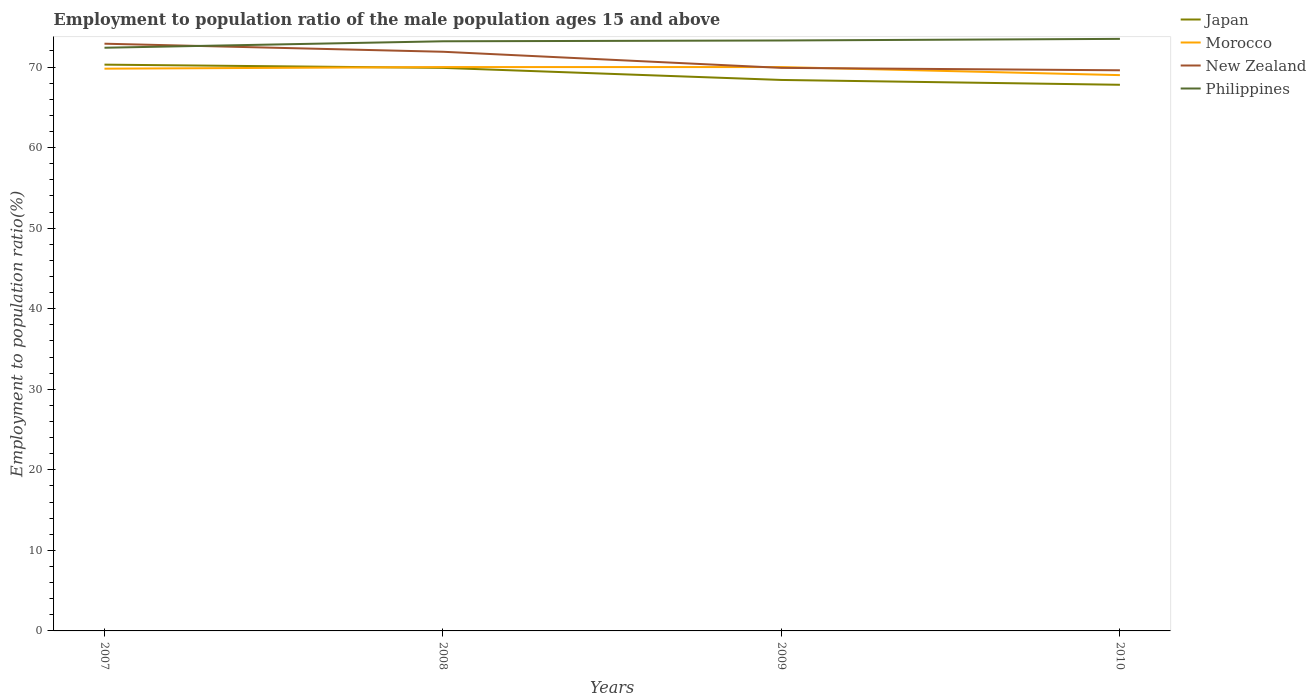How many different coloured lines are there?
Provide a succinct answer. 4. Does the line corresponding to Philippines intersect with the line corresponding to New Zealand?
Your answer should be compact. Yes. Across all years, what is the maximum employment to population ratio in New Zealand?
Give a very brief answer. 69.6. In which year was the employment to population ratio in Japan maximum?
Offer a very short reply. 2010. What is the total employment to population ratio in New Zealand in the graph?
Offer a very short reply. 2.3. How many years are there in the graph?
Ensure brevity in your answer.  4. Does the graph contain any zero values?
Your response must be concise. No. Where does the legend appear in the graph?
Provide a succinct answer. Top right. How are the legend labels stacked?
Give a very brief answer. Vertical. What is the title of the graph?
Make the answer very short. Employment to population ratio of the male population ages 15 and above. Does "Dominica" appear as one of the legend labels in the graph?
Your answer should be very brief. No. What is the Employment to population ratio(%) in Japan in 2007?
Make the answer very short. 70.3. What is the Employment to population ratio(%) in Morocco in 2007?
Give a very brief answer. 69.8. What is the Employment to population ratio(%) of New Zealand in 2007?
Your answer should be very brief. 72.9. What is the Employment to population ratio(%) of Philippines in 2007?
Keep it short and to the point. 72.4. What is the Employment to population ratio(%) in Japan in 2008?
Offer a very short reply. 69.9. What is the Employment to population ratio(%) in Morocco in 2008?
Provide a succinct answer. 70. What is the Employment to population ratio(%) of New Zealand in 2008?
Offer a very short reply. 71.9. What is the Employment to population ratio(%) of Philippines in 2008?
Provide a short and direct response. 73.2. What is the Employment to population ratio(%) in Japan in 2009?
Ensure brevity in your answer.  68.4. What is the Employment to population ratio(%) of New Zealand in 2009?
Keep it short and to the point. 69.9. What is the Employment to population ratio(%) in Philippines in 2009?
Give a very brief answer. 73.3. What is the Employment to population ratio(%) of Japan in 2010?
Provide a short and direct response. 67.8. What is the Employment to population ratio(%) in New Zealand in 2010?
Provide a succinct answer. 69.6. What is the Employment to population ratio(%) of Philippines in 2010?
Provide a succinct answer. 73.5. Across all years, what is the maximum Employment to population ratio(%) in Japan?
Provide a succinct answer. 70.3. Across all years, what is the maximum Employment to population ratio(%) of Morocco?
Your response must be concise. 70. Across all years, what is the maximum Employment to population ratio(%) of New Zealand?
Your answer should be very brief. 72.9. Across all years, what is the maximum Employment to population ratio(%) of Philippines?
Give a very brief answer. 73.5. Across all years, what is the minimum Employment to population ratio(%) of Japan?
Make the answer very short. 67.8. Across all years, what is the minimum Employment to population ratio(%) of New Zealand?
Offer a terse response. 69.6. Across all years, what is the minimum Employment to population ratio(%) of Philippines?
Your answer should be compact. 72.4. What is the total Employment to population ratio(%) in Japan in the graph?
Ensure brevity in your answer.  276.4. What is the total Employment to population ratio(%) of Morocco in the graph?
Ensure brevity in your answer.  278.8. What is the total Employment to population ratio(%) of New Zealand in the graph?
Keep it short and to the point. 284.3. What is the total Employment to population ratio(%) in Philippines in the graph?
Your answer should be very brief. 292.4. What is the difference between the Employment to population ratio(%) in Japan in 2007 and that in 2008?
Provide a short and direct response. 0.4. What is the difference between the Employment to population ratio(%) of Morocco in 2007 and that in 2008?
Provide a succinct answer. -0.2. What is the difference between the Employment to population ratio(%) of Philippines in 2007 and that in 2008?
Offer a terse response. -0.8. What is the difference between the Employment to population ratio(%) of Morocco in 2007 and that in 2009?
Make the answer very short. -0.2. What is the difference between the Employment to population ratio(%) of Japan in 2007 and that in 2010?
Provide a short and direct response. 2.5. What is the difference between the Employment to population ratio(%) of Japan in 2008 and that in 2009?
Your answer should be compact. 1.5. What is the difference between the Employment to population ratio(%) in Morocco in 2008 and that in 2009?
Your response must be concise. 0. What is the difference between the Employment to population ratio(%) of New Zealand in 2008 and that in 2009?
Ensure brevity in your answer.  2. What is the difference between the Employment to population ratio(%) in Philippines in 2008 and that in 2009?
Ensure brevity in your answer.  -0.1. What is the difference between the Employment to population ratio(%) of New Zealand in 2008 and that in 2010?
Provide a short and direct response. 2.3. What is the difference between the Employment to population ratio(%) of Japan in 2009 and that in 2010?
Your answer should be very brief. 0.6. What is the difference between the Employment to population ratio(%) of Philippines in 2009 and that in 2010?
Provide a succinct answer. -0.2. What is the difference between the Employment to population ratio(%) in Japan in 2007 and the Employment to population ratio(%) in New Zealand in 2008?
Offer a terse response. -1.6. What is the difference between the Employment to population ratio(%) of Japan in 2007 and the Employment to population ratio(%) of Philippines in 2008?
Provide a succinct answer. -2.9. What is the difference between the Employment to population ratio(%) of Morocco in 2007 and the Employment to population ratio(%) of New Zealand in 2008?
Offer a very short reply. -2.1. What is the difference between the Employment to population ratio(%) of New Zealand in 2007 and the Employment to population ratio(%) of Philippines in 2008?
Your answer should be very brief. -0.3. What is the difference between the Employment to population ratio(%) of Japan in 2007 and the Employment to population ratio(%) of Philippines in 2009?
Give a very brief answer. -3. What is the difference between the Employment to population ratio(%) of Morocco in 2007 and the Employment to population ratio(%) of Philippines in 2009?
Your answer should be compact. -3.5. What is the difference between the Employment to population ratio(%) in New Zealand in 2007 and the Employment to population ratio(%) in Philippines in 2010?
Provide a short and direct response. -0.6. What is the difference between the Employment to population ratio(%) of Japan in 2008 and the Employment to population ratio(%) of Morocco in 2009?
Ensure brevity in your answer.  -0.1. What is the difference between the Employment to population ratio(%) of Japan in 2008 and the Employment to population ratio(%) of Philippines in 2009?
Give a very brief answer. -3.4. What is the difference between the Employment to population ratio(%) of Morocco in 2008 and the Employment to population ratio(%) of New Zealand in 2009?
Offer a terse response. 0.1. What is the difference between the Employment to population ratio(%) in Morocco in 2008 and the Employment to population ratio(%) in Philippines in 2009?
Your response must be concise. -3.3. What is the difference between the Employment to population ratio(%) in New Zealand in 2008 and the Employment to population ratio(%) in Philippines in 2009?
Provide a succinct answer. -1.4. What is the difference between the Employment to population ratio(%) of Japan in 2008 and the Employment to population ratio(%) of Morocco in 2010?
Provide a succinct answer. 0.9. What is the difference between the Employment to population ratio(%) in Morocco in 2008 and the Employment to population ratio(%) in New Zealand in 2010?
Ensure brevity in your answer.  0.4. What is the difference between the Employment to population ratio(%) in Morocco in 2008 and the Employment to population ratio(%) in Philippines in 2010?
Ensure brevity in your answer.  -3.5. What is the difference between the Employment to population ratio(%) of New Zealand in 2008 and the Employment to population ratio(%) of Philippines in 2010?
Make the answer very short. -1.6. What is the difference between the Employment to population ratio(%) of Japan in 2009 and the Employment to population ratio(%) of Morocco in 2010?
Give a very brief answer. -0.6. What is the difference between the Employment to population ratio(%) in Japan in 2009 and the Employment to population ratio(%) in Philippines in 2010?
Your answer should be very brief. -5.1. What is the difference between the Employment to population ratio(%) of Morocco in 2009 and the Employment to population ratio(%) of New Zealand in 2010?
Make the answer very short. 0.4. What is the difference between the Employment to population ratio(%) in New Zealand in 2009 and the Employment to population ratio(%) in Philippines in 2010?
Offer a terse response. -3.6. What is the average Employment to population ratio(%) in Japan per year?
Your response must be concise. 69.1. What is the average Employment to population ratio(%) in Morocco per year?
Provide a short and direct response. 69.7. What is the average Employment to population ratio(%) in New Zealand per year?
Your answer should be very brief. 71.08. What is the average Employment to population ratio(%) in Philippines per year?
Offer a terse response. 73.1. In the year 2007, what is the difference between the Employment to population ratio(%) of Japan and Employment to population ratio(%) of New Zealand?
Provide a short and direct response. -2.6. In the year 2007, what is the difference between the Employment to population ratio(%) in Japan and Employment to population ratio(%) in Philippines?
Ensure brevity in your answer.  -2.1. In the year 2007, what is the difference between the Employment to population ratio(%) of Morocco and Employment to population ratio(%) of Philippines?
Provide a short and direct response. -2.6. In the year 2008, what is the difference between the Employment to population ratio(%) in Japan and Employment to population ratio(%) in Philippines?
Your response must be concise. -3.3. In the year 2009, what is the difference between the Employment to population ratio(%) in Japan and Employment to population ratio(%) in Morocco?
Provide a short and direct response. -1.6. In the year 2010, what is the difference between the Employment to population ratio(%) of Japan and Employment to population ratio(%) of Morocco?
Offer a very short reply. -1.2. In the year 2010, what is the difference between the Employment to population ratio(%) of Japan and Employment to population ratio(%) of New Zealand?
Provide a succinct answer. -1.8. In the year 2010, what is the difference between the Employment to population ratio(%) in Japan and Employment to population ratio(%) in Philippines?
Keep it short and to the point. -5.7. In the year 2010, what is the difference between the Employment to population ratio(%) in Morocco and Employment to population ratio(%) in Philippines?
Make the answer very short. -4.5. In the year 2010, what is the difference between the Employment to population ratio(%) of New Zealand and Employment to population ratio(%) of Philippines?
Your answer should be very brief. -3.9. What is the ratio of the Employment to population ratio(%) of Japan in 2007 to that in 2008?
Your response must be concise. 1.01. What is the ratio of the Employment to population ratio(%) in Morocco in 2007 to that in 2008?
Provide a succinct answer. 1. What is the ratio of the Employment to population ratio(%) of New Zealand in 2007 to that in 2008?
Give a very brief answer. 1.01. What is the ratio of the Employment to population ratio(%) of Japan in 2007 to that in 2009?
Your answer should be very brief. 1.03. What is the ratio of the Employment to population ratio(%) of New Zealand in 2007 to that in 2009?
Your answer should be compact. 1.04. What is the ratio of the Employment to population ratio(%) of Japan in 2007 to that in 2010?
Offer a very short reply. 1.04. What is the ratio of the Employment to population ratio(%) in Morocco in 2007 to that in 2010?
Keep it short and to the point. 1.01. What is the ratio of the Employment to population ratio(%) of New Zealand in 2007 to that in 2010?
Your response must be concise. 1.05. What is the ratio of the Employment to population ratio(%) in Japan in 2008 to that in 2009?
Provide a short and direct response. 1.02. What is the ratio of the Employment to population ratio(%) in Morocco in 2008 to that in 2009?
Offer a terse response. 1. What is the ratio of the Employment to population ratio(%) of New Zealand in 2008 to that in 2009?
Give a very brief answer. 1.03. What is the ratio of the Employment to population ratio(%) in Japan in 2008 to that in 2010?
Offer a terse response. 1.03. What is the ratio of the Employment to population ratio(%) of Morocco in 2008 to that in 2010?
Your response must be concise. 1.01. What is the ratio of the Employment to population ratio(%) of New Zealand in 2008 to that in 2010?
Give a very brief answer. 1.03. What is the ratio of the Employment to population ratio(%) of Japan in 2009 to that in 2010?
Provide a short and direct response. 1.01. What is the ratio of the Employment to population ratio(%) of Morocco in 2009 to that in 2010?
Give a very brief answer. 1.01. What is the difference between the highest and the second highest Employment to population ratio(%) of Japan?
Your answer should be compact. 0.4. What is the difference between the highest and the second highest Employment to population ratio(%) of Philippines?
Offer a very short reply. 0.2. What is the difference between the highest and the lowest Employment to population ratio(%) in Japan?
Offer a terse response. 2.5. What is the difference between the highest and the lowest Employment to population ratio(%) of Morocco?
Ensure brevity in your answer.  1. What is the difference between the highest and the lowest Employment to population ratio(%) in Philippines?
Your answer should be compact. 1.1. 